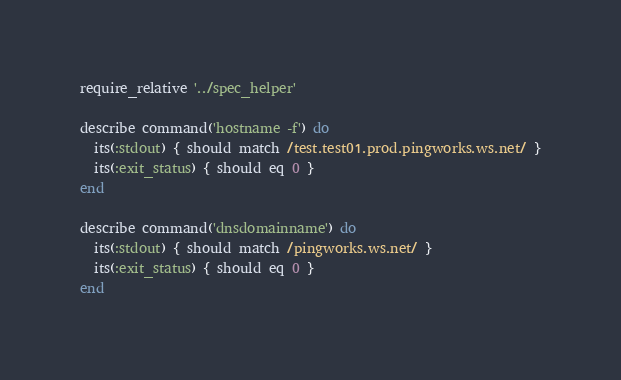<code> <loc_0><loc_0><loc_500><loc_500><_Ruby_>require_relative '../spec_helper'

describe command('hostname -f') do
  its(:stdout) { should match /test.test01.prod.pingworks.ws.net/ }
  its(:exit_status) { should eq 0 }
end

describe command('dnsdomainname') do
  its(:stdout) { should match /pingworks.ws.net/ }
  its(:exit_status) { should eq 0 }
end
</code> 